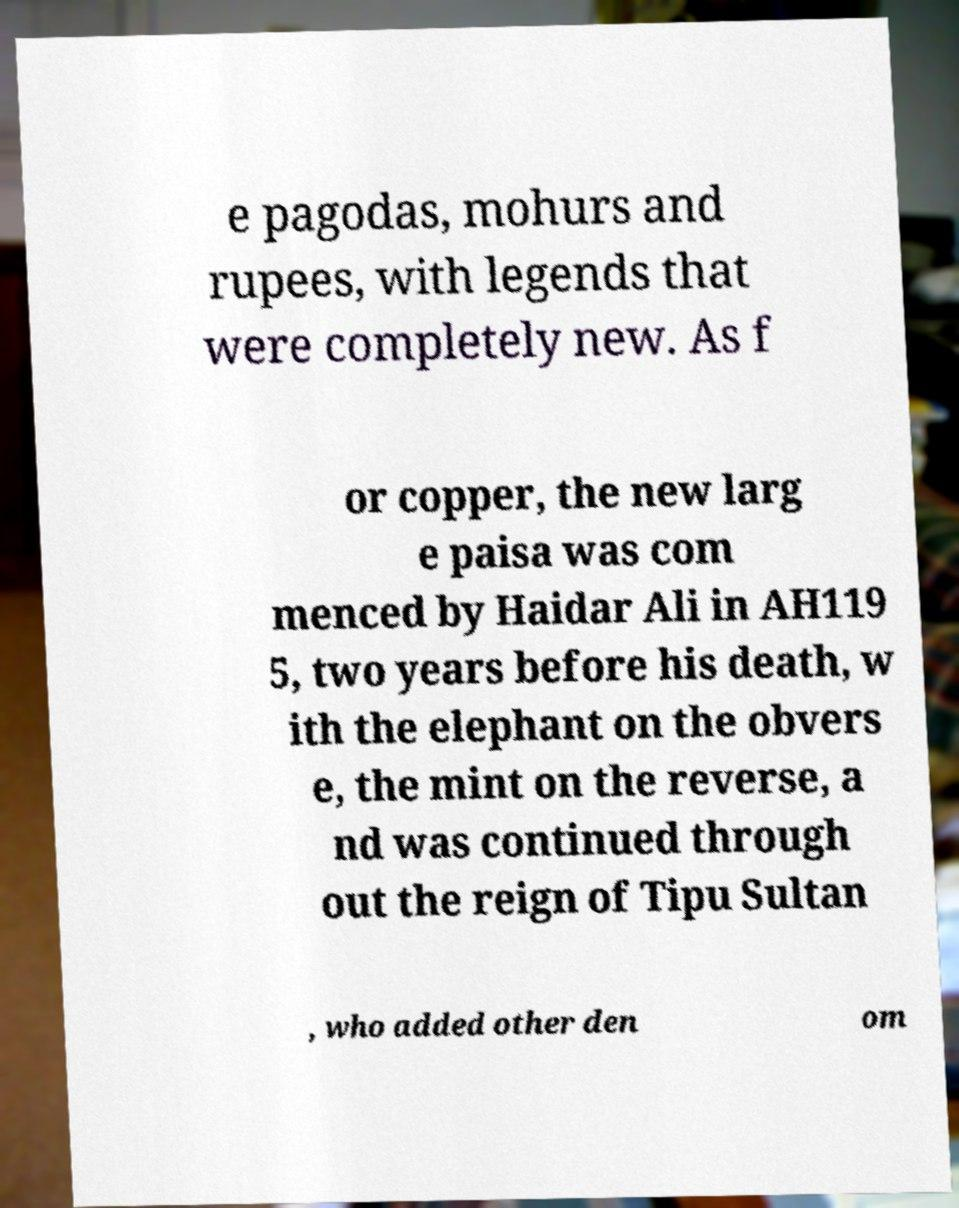Can you read and provide the text displayed in the image?This photo seems to have some interesting text. Can you extract and type it out for me? e pagodas, mohurs and rupees, with legends that were completely new. As f or copper, the new larg e paisa was com menced by Haidar Ali in AH119 5, two years before his death, w ith the elephant on the obvers e, the mint on the reverse, a nd was continued through out the reign of Tipu Sultan , who added other den om 